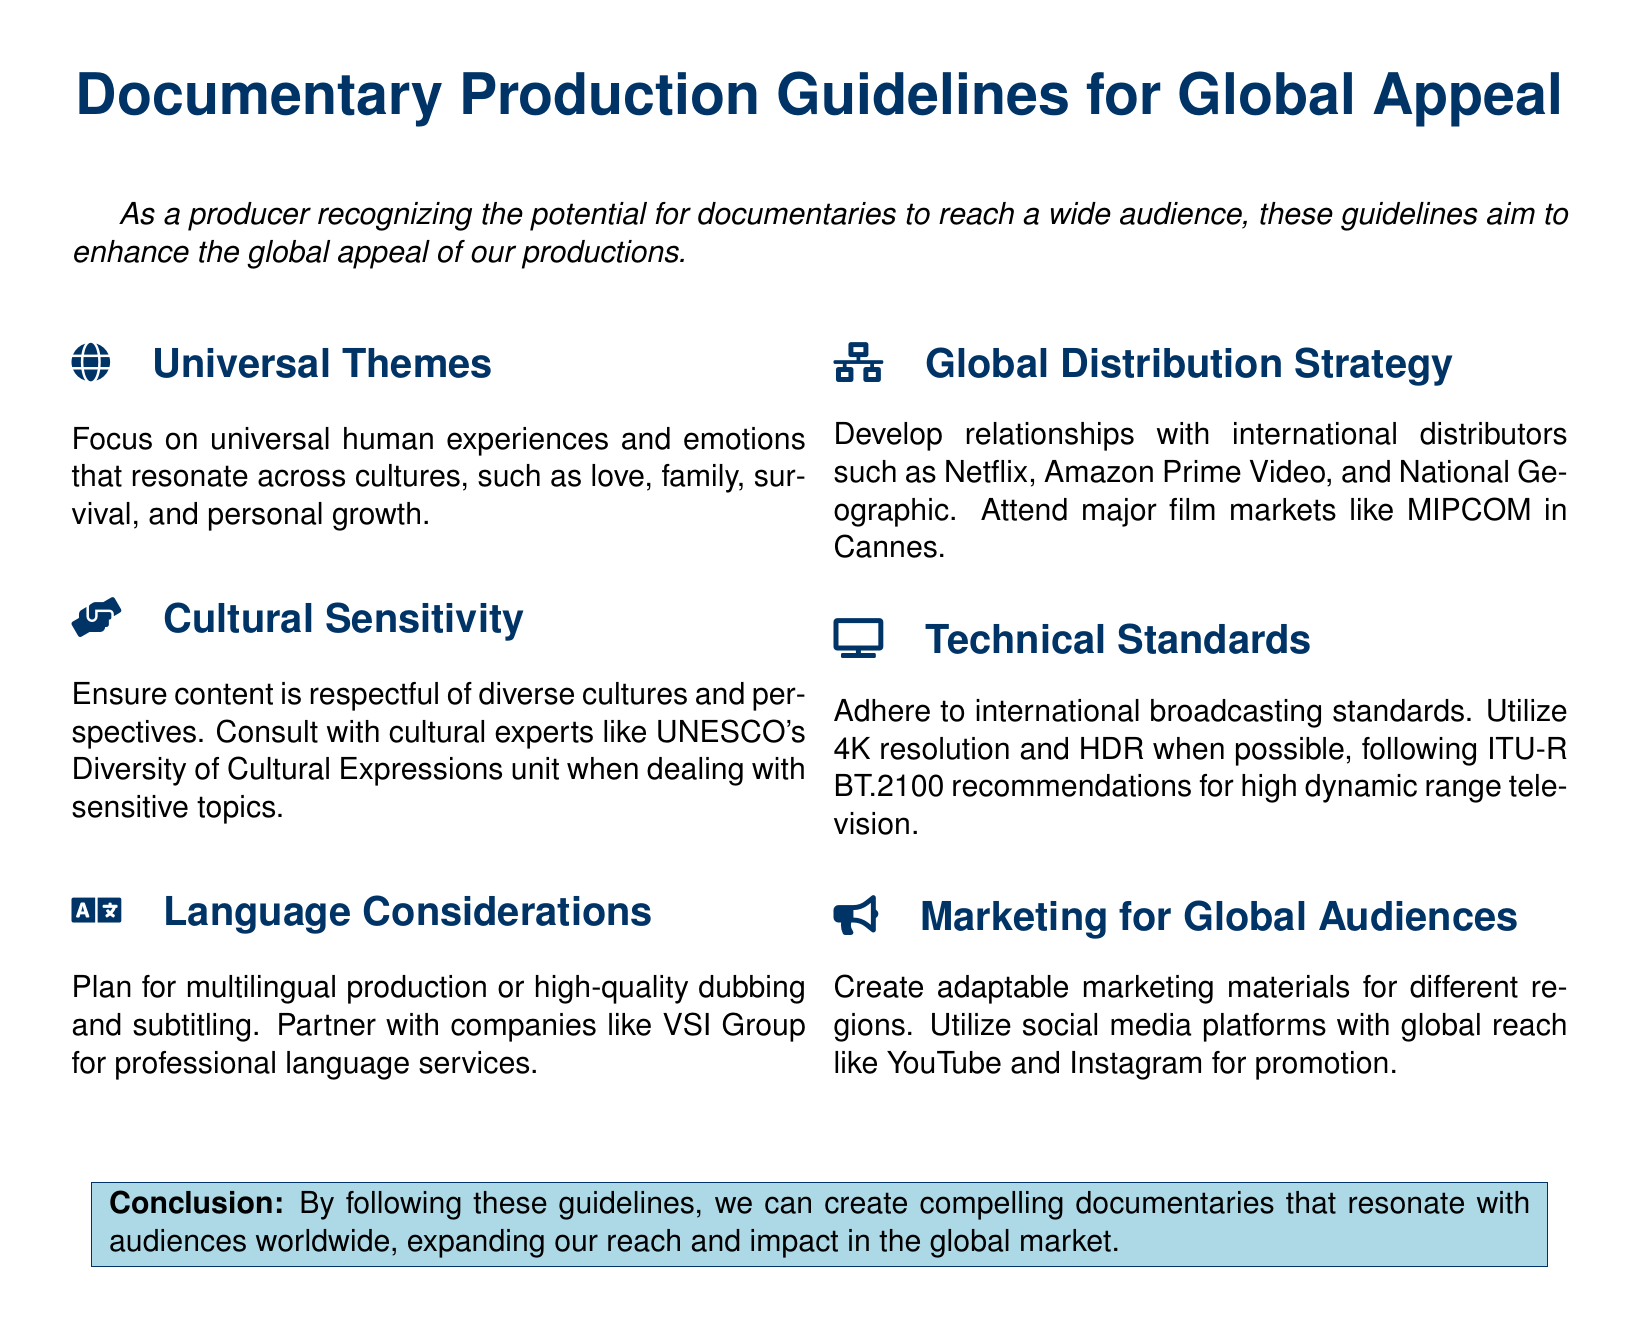What are universal themes? Universal themes are human experiences and emotions that resonate across cultures.
Answer: Love, family, survival, and personal growth What must content ensure regarding cultural perspectives? Content must be respectful of diverse cultures and perspectives.
Answer: Cultural sensitivity Which organization should be consulted for sensitive topics? The document mentions consulting experts for cultural sensitivity.
Answer: UNESCO's Diversity of Cultural Expressions unit What resolution is recommended for broadcasting standards? The document specifies a resolution to adhere to for international broadcasting standards.
Answer: 4K resolution What is a recommended strategy for global distribution? The document suggests developing relationships with international distributors.
Answer: Global distribution strategy What should marketing materials be? The document states that marketing materials need to be adaptable for various regions.
Answer: Adaptable Which social media platforms are mentioned for promotion? The document lists social media platforms that have global reach for marketing purposes.
Answer: YouTube and Instagram What does the conclusion emphasize? The conclusion discusses the importance of the guidelines for documentaries.
Answer: Compelling documentaries What technical recommendation is given for television? The document outlines a technical standard for high dynamic range television.
Answer: HDR 